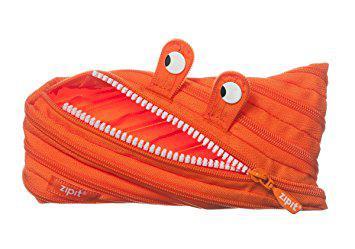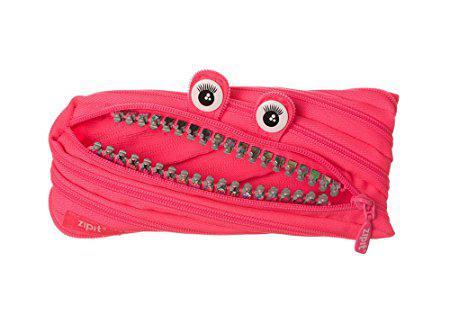The first image is the image on the left, the second image is the image on the right. Assess this claim about the two images: "At least one of the pouches has holes along the top to fit it into a three-ring binder.". Correct or not? Answer yes or no. No. The first image is the image on the left, the second image is the image on the right. Evaluate the accuracy of this statement regarding the images: "One pouch is pink and the other pouch is red.". Is it true? Answer yes or no. No. 